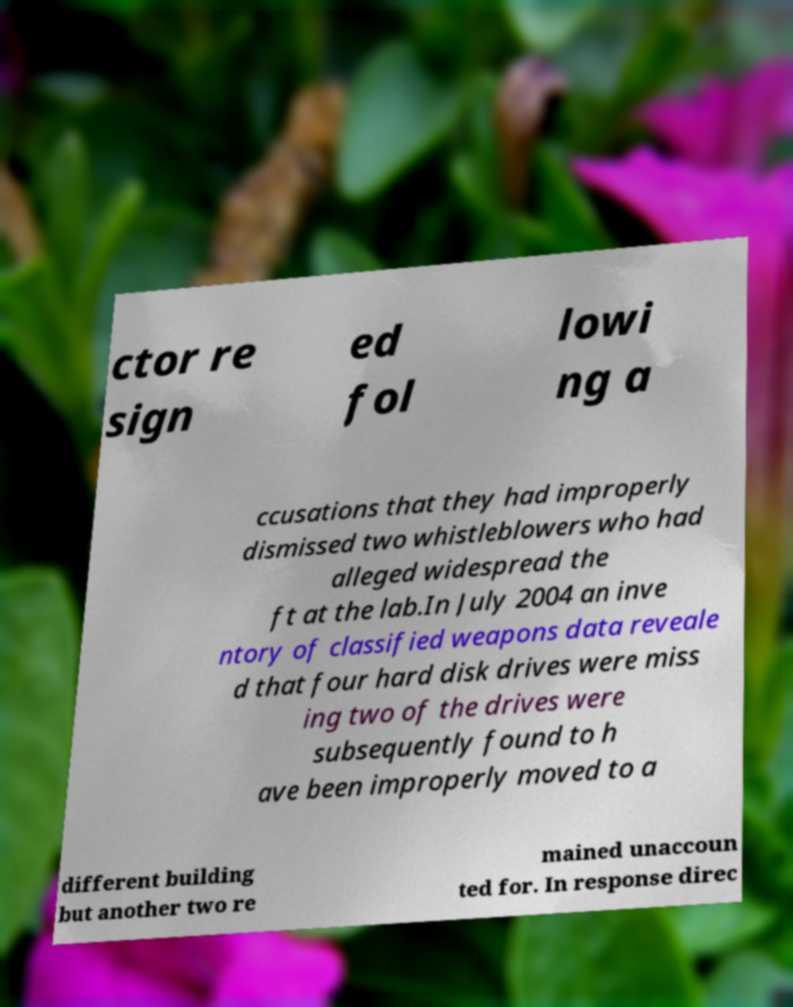Please read and relay the text visible in this image. What does it say? ctor re sign ed fol lowi ng a ccusations that they had improperly dismissed two whistleblowers who had alleged widespread the ft at the lab.In July 2004 an inve ntory of classified weapons data reveale d that four hard disk drives were miss ing two of the drives were subsequently found to h ave been improperly moved to a different building but another two re mained unaccoun ted for. In response direc 